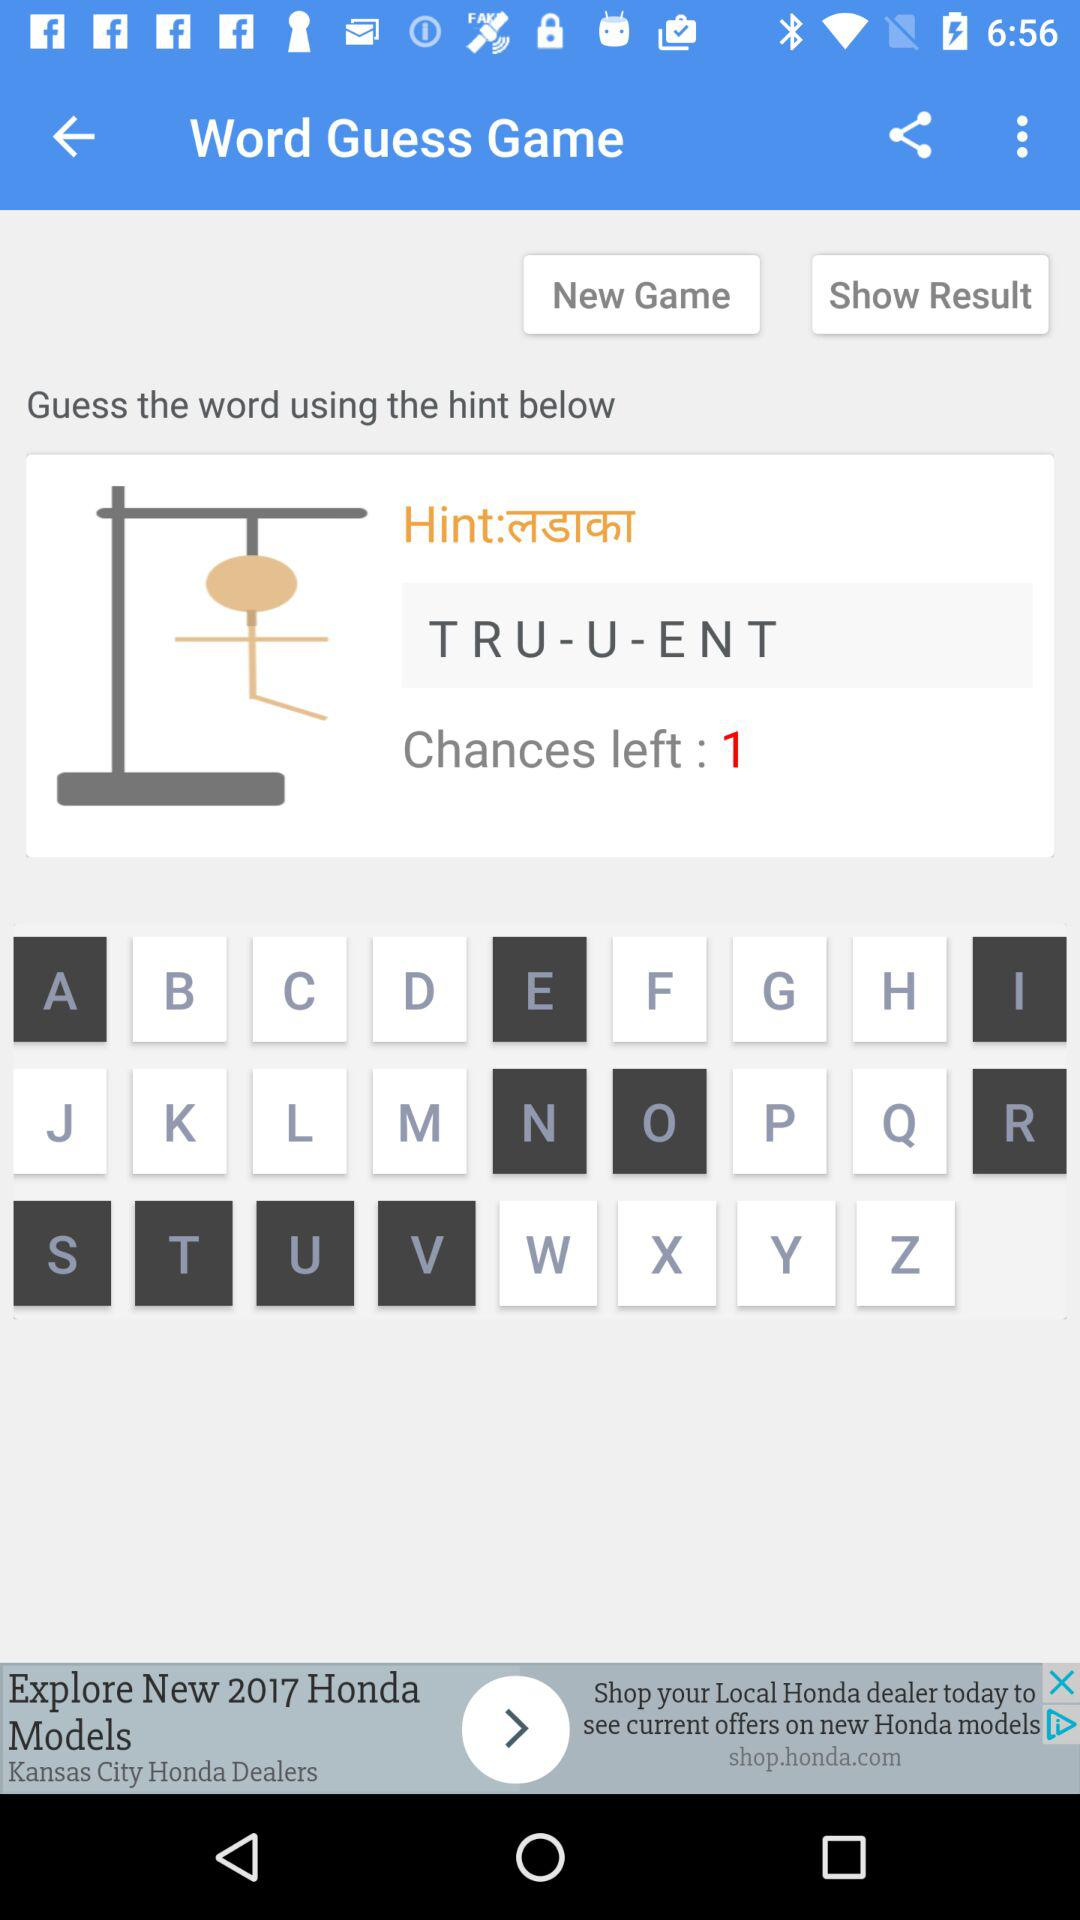How many chances are left in the "Word Guess Game"? There is one chance left. 